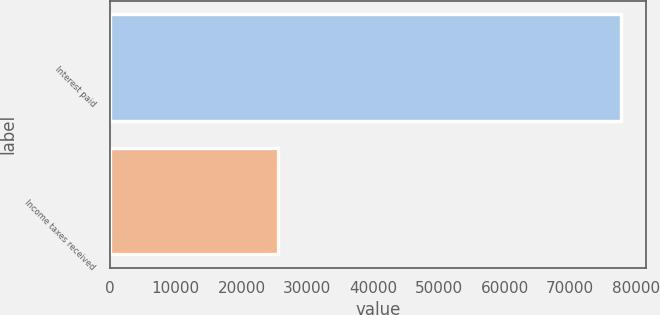Convert chart. <chart><loc_0><loc_0><loc_500><loc_500><bar_chart><fcel>Interest paid<fcel>Income taxes received<nl><fcel>77663<fcel>25581<nl></chart> 